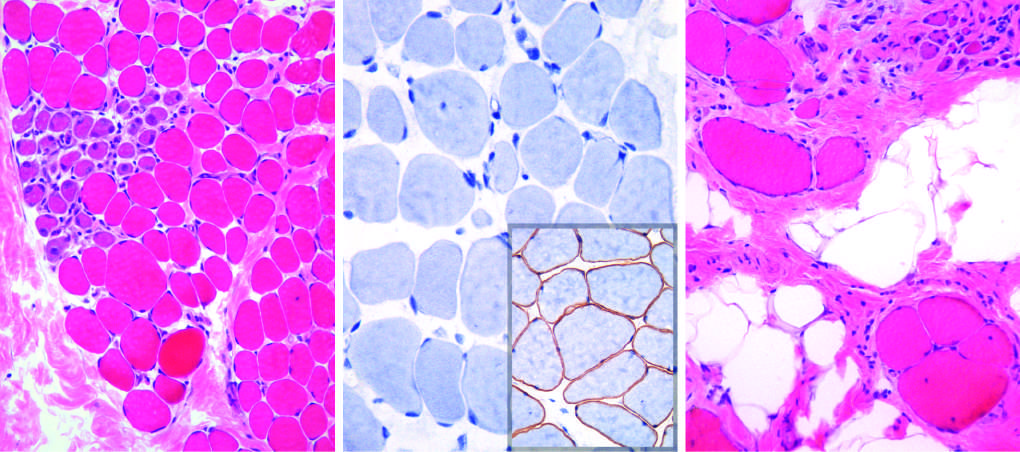what is there regenerating myofibers and slight endomysial fibrosis, seen as focal pink-staining connective tissue between myofibers?
Answer the question using a single word or phrase. A cluster of basophilic 